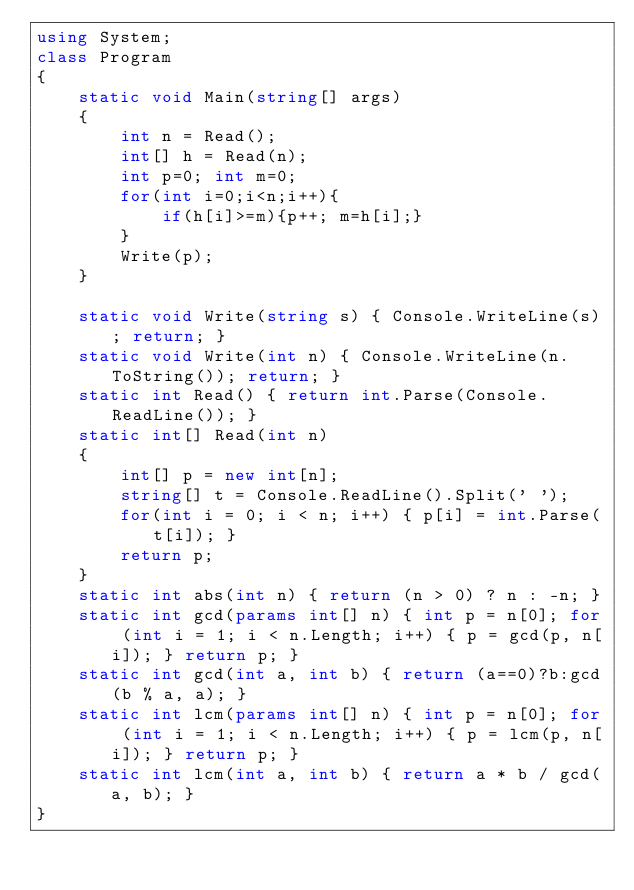Convert code to text. <code><loc_0><loc_0><loc_500><loc_500><_C#_>using System;
class Program
{
    static void Main(string[] args)
    {
        int n = Read();
        int[] h = Read(n);
        int p=0; int m=0;
        for(int i=0;i<n;i++){
            if(h[i]>=m){p++; m=h[i];}
        }
        Write(p);
    }

    static void Write(string s) { Console.WriteLine(s); return; }
    static void Write(int n) { Console.WriteLine(n.ToString()); return; }
    static int Read() { return int.Parse(Console.ReadLine()); }
    static int[] Read(int n)
    {
        int[] p = new int[n];
        string[] t = Console.ReadLine().Split(' ');
        for(int i = 0; i < n; i++) { p[i] = int.Parse(t[i]); }
        return p;
    }
    static int abs(int n) { return (n > 0) ? n : -n; }
    static int gcd(params int[] n) { int p = n[0]; for (int i = 1; i < n.Length; i++) { p = gcd(p, n[i]); } return p; }
    static int gcd(int a, int b) { return (a==0)?b:gcd(b % a, a); }
    static int lcm(params int[] n) { int p = n[0]; for (int i = 1; i < n.Length; i++) { p = lcm(p, n[i]); } return p; }
    static int lcm(int a, int b) { return a * b / gcd(a, b); }
}
</code> 